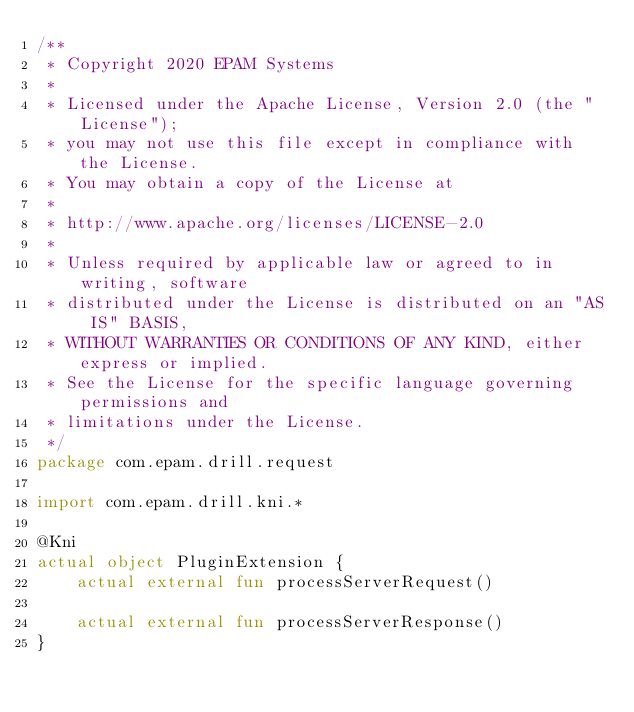<code> <loc_0><loc_0><loc_500><loc_500><_Kotlin_>/**
 * Copyright 2020 EPAM Systems
 *
 * Licensed under the Apache License, Version 2.0 (the "License");
 * you may not use this file except in compliance with the License.
 * You may obtain a copy of the License at
 *
 * http://www.apache.org/licenses/LICENSE-2.0
 *
 * Unless required by applicable law or agreed to in writing, software
 * distributed under the License is distributed on an "AS IS" BASIS,
 * WITHOUT WARRANTIES OR CONDITIONS OF ANY KIND, either express or implied.
 * See the License for the specific language governing permissions and
 * limitations under the License.
 */
package com.epam.drill.request

import com.epam.drill.kni.*

@Kni
actual object PluginExtension {
    actual external fun processServerRequest()

    actual external fun processServerResponse()
}
</code> 